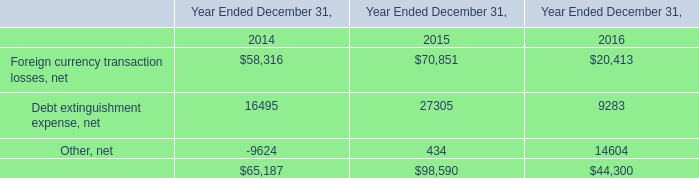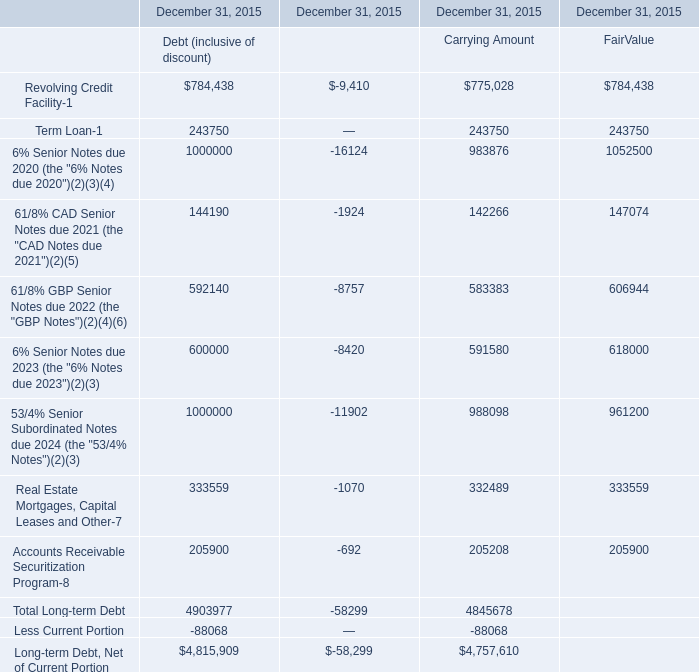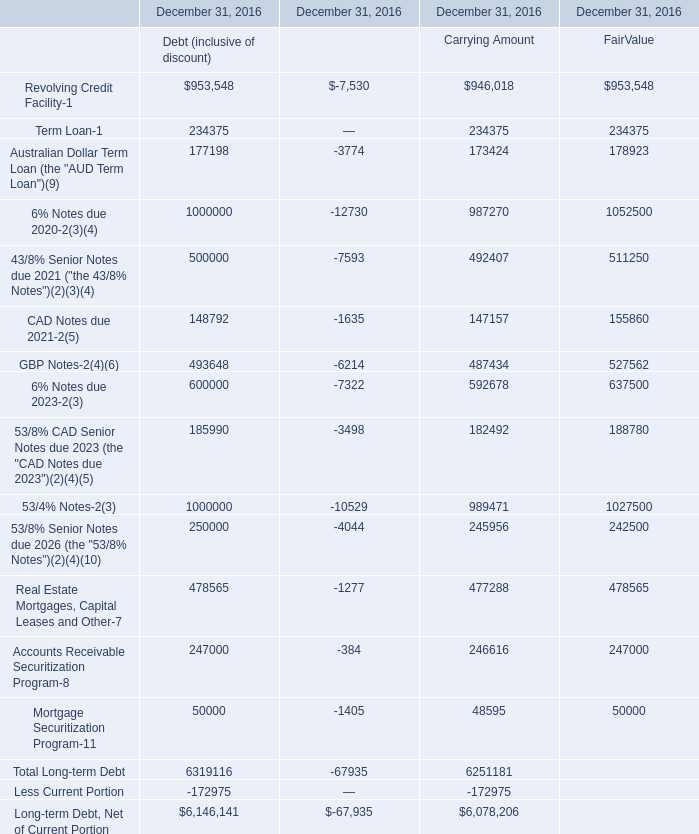In the section with largest amount of Total Long-term Debt, what's the sum of Long-term Debt, Net of Current Portion? (in thousand) 
Computations: (6319116 - 172975)
Answer: 6146141.0. 